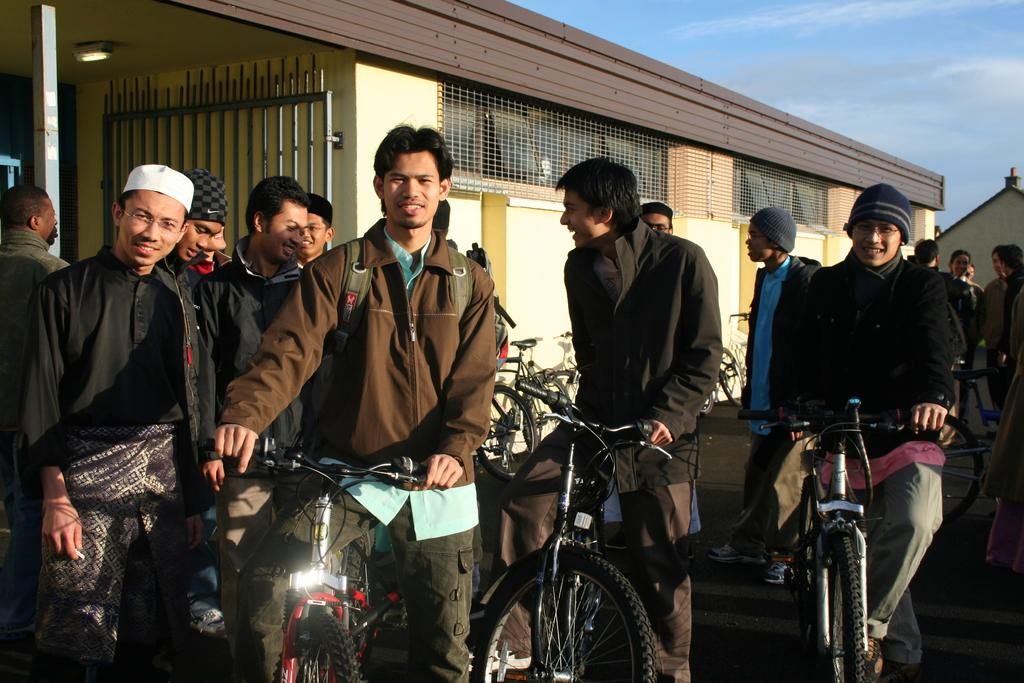What is happening on the road in the image? There are persons on the road in the image. What are the persons using for transportation? There are bicycles in the image. What can be seen in the background of the image? There is a house and the sky visible in the background of the image. What is the source of illumination in the image? There is a light in the image. How many birds are flying over the water in the image? There are no birds or water present in the image. What type of muscle is being exercised by the persons on the bicycles in the image? The image does not provide information about the muscles being exercised by the persons on the bicycles. 